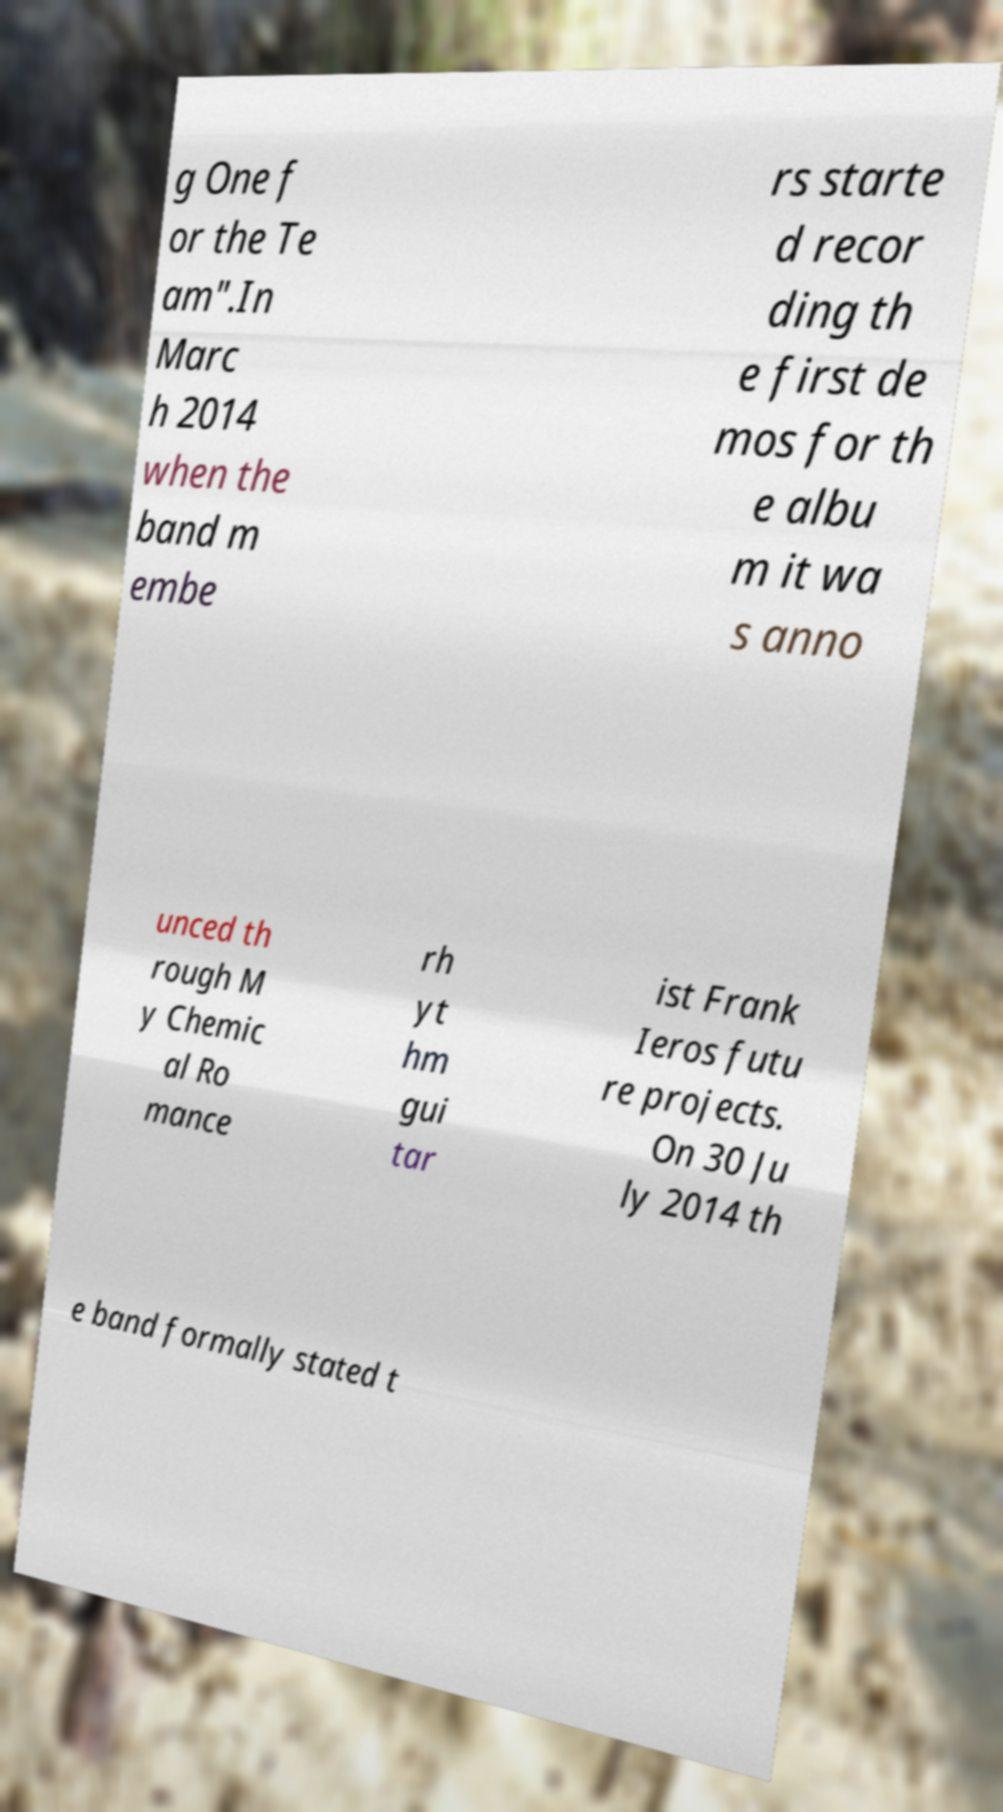Could you extract and type out the text from this image? g One f or the Te am".In Marc h 2014 when the band m embe rs starte d recor ding th e first de mos for th e albu m it wa s anno unced th rough M y Chemic al Ro mance rh yt hm gui tar ist Frank Ieros futu re projects. On 30 Ju ly 2014 th e band formally stated t 